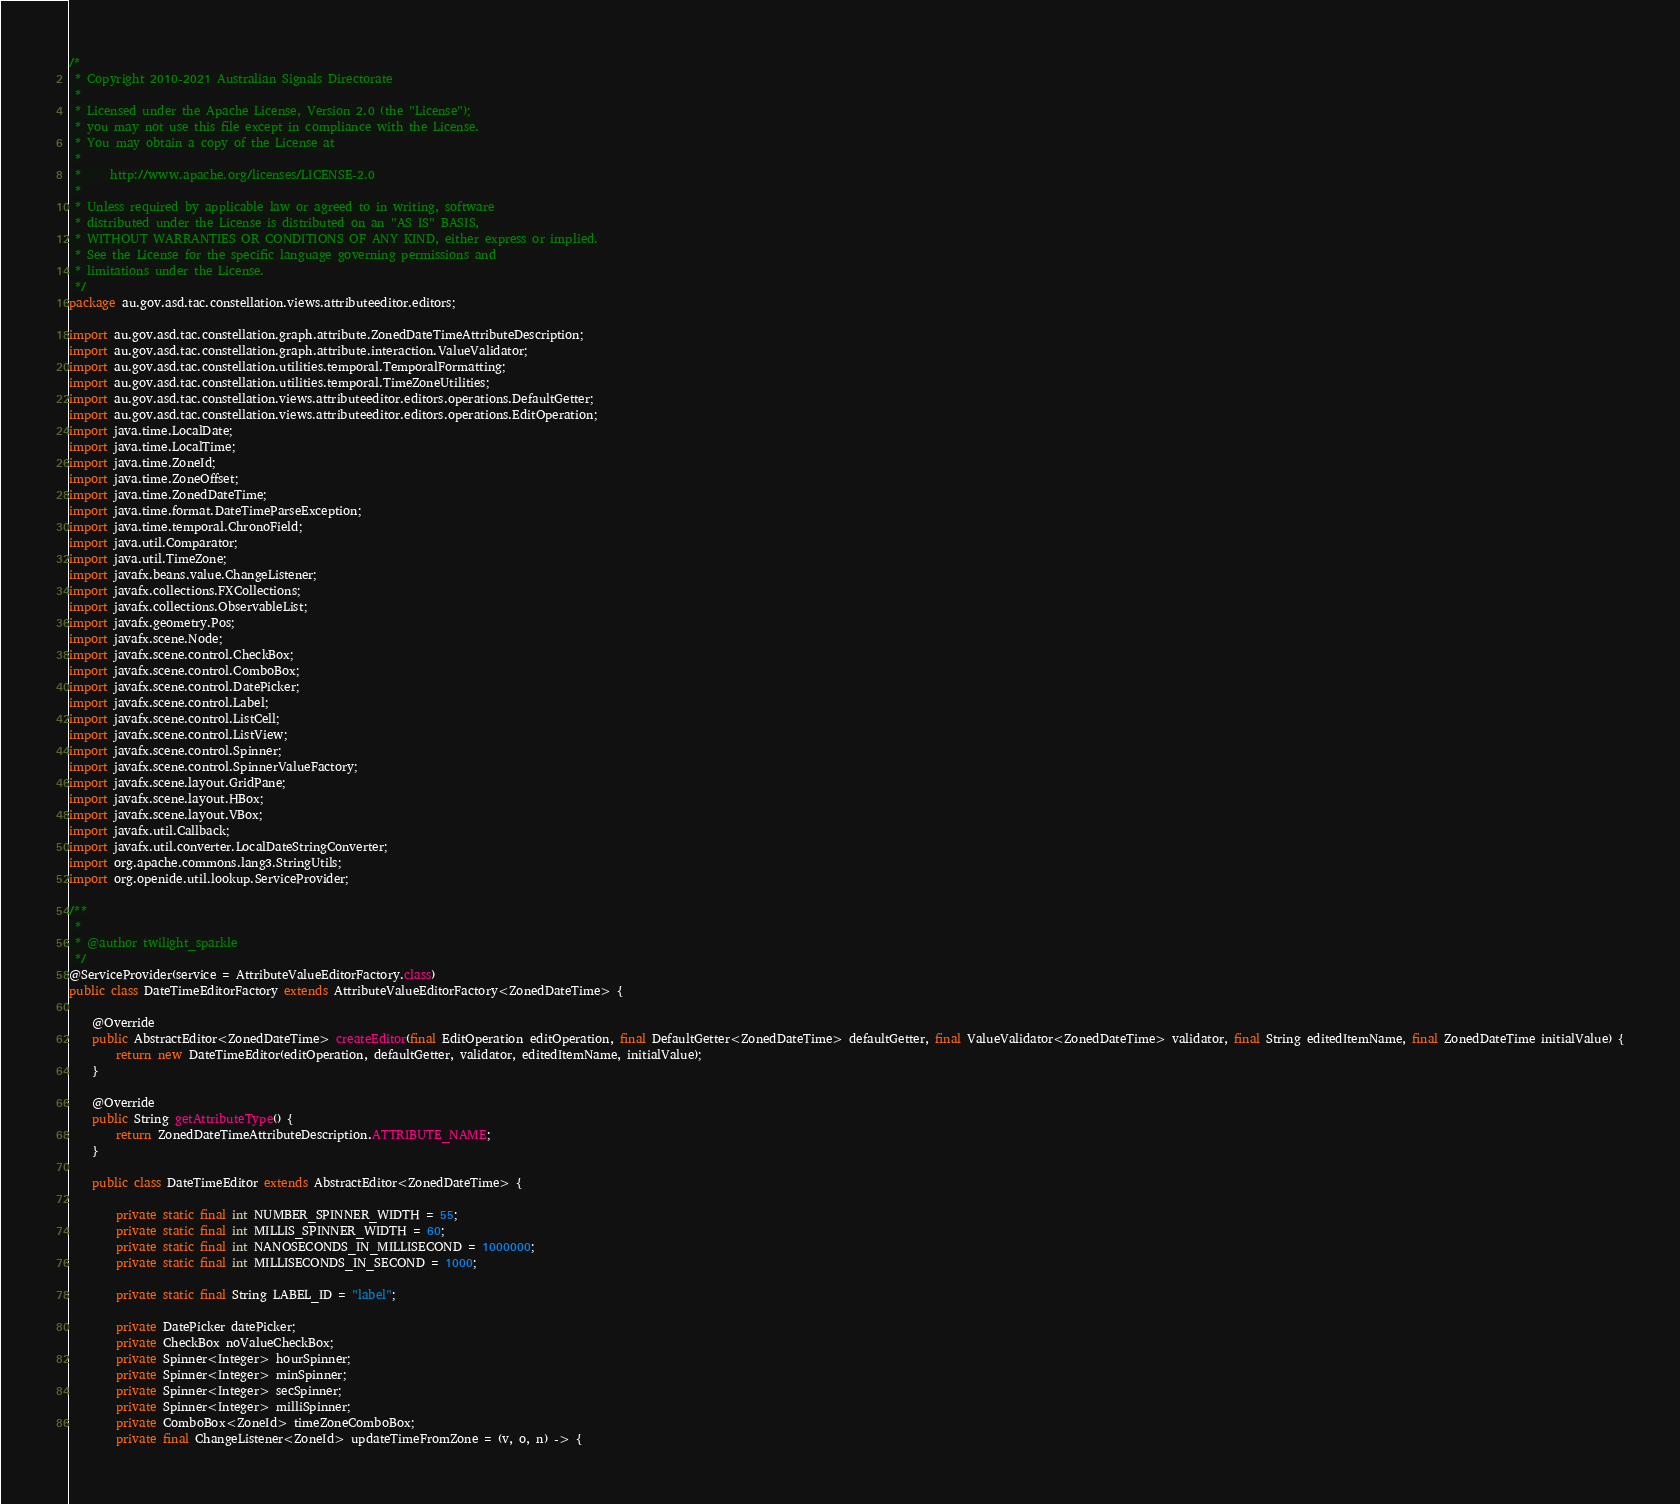Convert code to text. <code><loc_0><loc_0><loc_500><loc_500><_Java_>/*
 * Copyright 2010-2021 Australian Signals Directorate
 *
 * Licensed under the Apache License, Version 2.0 (the "License");
 * you may not use this file except in compliance with the License.
 * You may obtain a copy of the License at
 *
 *     http://www.apache.org/licenses/LICENSE-2.0
 *
 * Unless required by applicable law or agreed to in writing, software
 * distributed under the License is distributed on an "AS IS" BASIS,
 * WITHOUT WARRANTIES OR CONDITIONS OF ANY KIND, either express or implied.
 * See the License for the specific language governing permissions and
 * limitations under the License.
 */
package au.gov.asd.tac.constellation.views.attributeeditor.editors;

import au.gov.asd.tac.constellation.graph.attribute.ZonedDateTimeAttributeDescription;
import au.gov.asd.tac.constellation.graph.attribute.interaction.ValueValidator;
import au.gov.asd.tac.constellation.utilities.temporal.TemporalFormatting;
import au.gov.asd.tac.constellation.utilities.temporal.TimeZoneUtilities;
import au.gov.asd.tac.constellation.views.attributeeditor.editors.operations.DefaultGetter;
import au.gov.asd.tac.constellation.views.attributeeditor.editors.operations.EditOperation;
import java.time.LocalDate;
import java.time.LocalTime;
import java.time.ZoneId;
import java.time.ZoneOffset;
import java.time.ZonedDateTime;
import java.time.format.DateTimeParseException;
import java.time.temporal.ChronoField;
import java.util.Comparator;
import java.util.TimeZone;
import javafx.beans.value.ChangeListener;
import javafx.collections.FXCollections;
import javafx.collections.ObservableList;
import javafx.geometry.Pos;
import javafx.scene.Node;
import javafx.scene.control.CheckBox;
import javafx.scene.control.ComboBox;
import javafx.scene.control.DatePicker;
import javafx.scene.control.Label;
import javafx.scene.control.ListCell;
import javafx.scene.control.ListView;
import javafx.scene.control.Spinner;
import javafx.scene.control.SpinnerValueFactory;
import javafx.scene.layout.GridPane;
import javafx.scene.layout.HBox;
import javafx.scene.layout.VBox;
import javafx.util.Callback;
import javafx.util.converter.LocalDateStringConverter;
import org.apache.commons.lang3.StringUtils;
import org.openide.util.lookup.ServiceProvider;

/**
 *
 * @author twilight_sparkle
 */
@ServiceProvider(service = AttributeValueEditorFactory.class)
public class DateTimeEditorFactory extends AttributeValueEditorFactory<ZonedDateTime> {

    @Override
    public AbstractEditor<ZonedDateTime> createEditor(final EditOperation editOperation, final DefaultGetter<ZonedDateTime> defaultGetter, final ValueValidator<ZonedDateTime> validator, final String editedItemName, final ZonedDateTime initialValue) {
        return new DateTimeEditor(editOperation, defaultGetter, validator, editedItemName, initialValue);
    }

    @Override
    public String getAttributeType() {
        return ZonedDateTimeAttributeDescription.ATTRIBUTE_NAME;
    }

    public class DateTimeEditor extends AbstractEditor<ZonedDateTime> {

        private static final int NUMBER_SPINNER_WIDTH = 55;
        private static final int MILLIS_SPINNER_WIDTH = 60;
        private static final int NANOSECONDS_IN_MILLISECOND = 1000000;
        private static final int MILLISECONDS_IN_SECOND = 1000;

        private static final String LABEL_ID = "label";

        private DatePicker datePicker;
        private CheckBox noValueCheckBox;
        private Spinner<Integer> hourSpinner;
        private Spinner<Integer> minSpinner;
        private Spinner<Integer> secSpinner;
        private Spinner<Integer> milliSpinner;
        private ComboBox<ZoneId> timeZoneComboBox;
        private final ChangeListener<ZoneId> updateTimeFromZone = (v, o, n) -> {</code> 